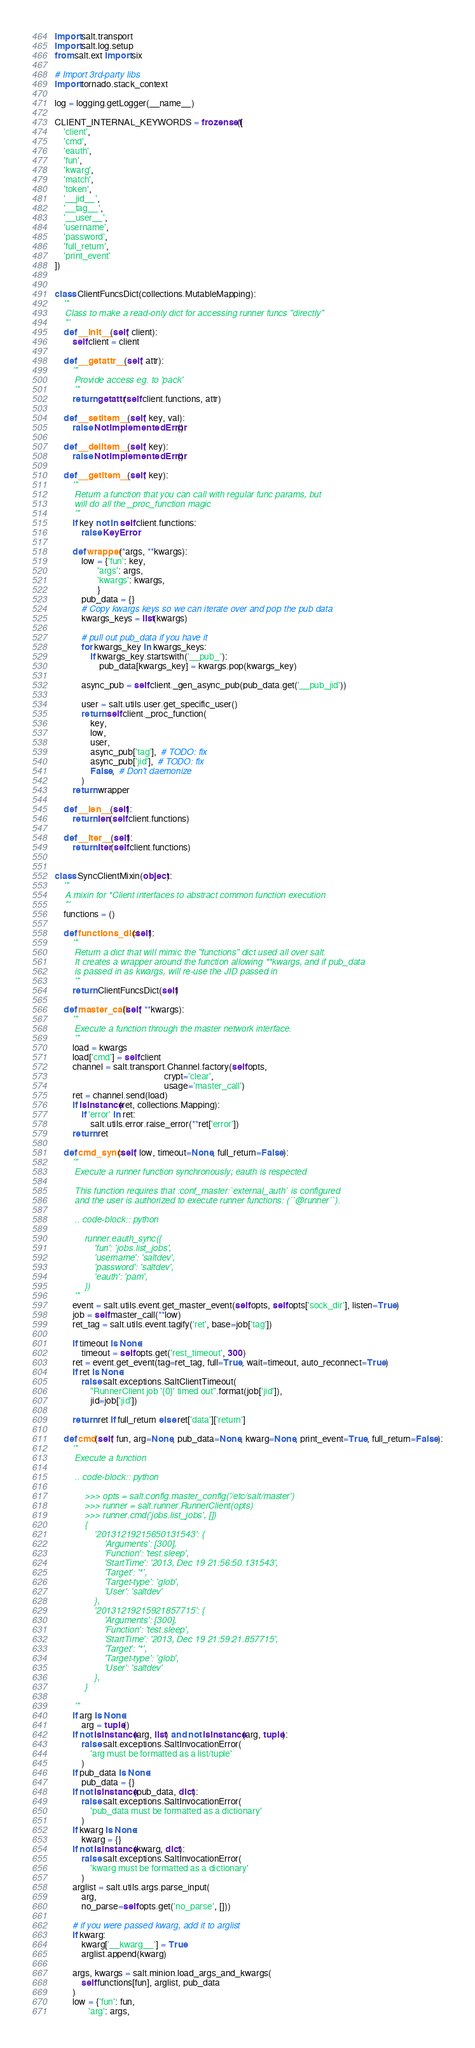<code> <loc_0><loc_0><loc_500><loc_500><_Python_>import salt.transport
import salt.log.setup
from salt.ext import six

# Import 3rd-party libs
import tornado.stack_context

log = logging.getLogger(__name__)

CLIENT_INTERNAL_KEYWORDS = frozenset([
    'client',
    'cmd',
    'eauth',
    'fun',
    'kwarg',
    'match',
    'token',
    '__jid__',
    '__tag__',
    '__user__',
    'username',
    'password',
    'full_return',
    'print_event'
])


class ClientFuncsDict(collections.MutableMapping):
    '''
    Class to make a read-only dict for accessing runner funcs "directly"
    '''
    def __init__(self, client):
        self.client = client

    def __getattr__(self, attr):
        '''
        Provide access eg. to 'pack'
        '''
        return getattr(self.client.functions, attr)

    def __setitem__(self, key, val):
        raise NotImplementedError()

    def __delitem__(self, key):
        raise NotImplementedError()

    def __getitem__(self, key):
        '''
        Return a function that you can call with regular func params, but
        will do all the _proc_function magic
        '''
        if key not in self.client.functions:
            raise KeyError

        def wrapper(*args, **kwargs):
            low = {'fun': key,
                   'args': args,
                   'kwargs': kwargs,
                   }
            pub_data = {}
            # Copy kwargs keys so we can iterate over and pop the pub data
            kwargs_keys = list(kwargs)

            # pull out pub_data if you have it
            for kwargs_key in kwargs_keys:
                if kwargs_key.startswith('__pub_'):
                    pub_data[kwargs_key] = kwargs.pop(kwargs_key)

            async_pub = self.client._gen_async_pub(pub_data.get('__pub_jid'))

            user = salt.utils.user.get_specific_user()
            return self.client._proc_function(
                key,
                low,
                user,
                async_pub['tag'],  # TODO: fix
                async_pub['jid'],  # TODO: fix
                False,  # Don't daemonize
            )
        return wrapper

    def __len__(self):
        return len(self.client.functions)

    def __iter__(self):
        return iter(self.client.functions)


class SyncClientMixin(object):
    '''
    A mixin for *Client interfaces to abstract common function execution
    '''
    functions = ()

    def functions_dict(self):
        '''
        Return a dict that will mimic the "functions" dict used all over salt.
        It creates a wrapper around the function allowing **kwargs, and if pub_data
        is passed in as kwargs, will re-use the JID passed in
        '''
        return ClientFuncsDict(self)

    def master_call(self, **kwargs):
        '''
        Execute a function through the master network interface.
        '''
        load = kwargs
        load['cmd'] = self.client
        channel = salt.transport.Channel.factory(self.opts,
                                                 crypt='clear',
                                                 usage='master_call')
        ret = channel.send(load)
        if isinstance(ret, collections.Mapping):
            if 'error' in ret:
                salt.utils.error.raise_error(**ret['error'])
        return ret

    def cmd_sync(self, low, timeout=None, full_return=False):
        '''
        Execute a runner function synchronously; eauth is respected

        This function requires that :conf_master:`external_auth` is configured
        and the user is authorized to execute runner functions: (``@runner``).

        .. code-block:: python

            runner.eauth_sync({
                'fun': 'jobs.list_jobs',
                'username': 'saltdev',
                'password': 'saltdev',
                'eauth': 'pam',
            })
        '''
        event = salt.utils.event.get_master_event(self.opts, self.opts['sock_dir'], listen=True)
        job = self.master_call(**low)
        ret_tag = salt.utils.event.tagify('ret', base=job['tag'])

        if timeout is None:
            timeout = self.opts.get('rest_timeout', 300)
        ret = event.get_event(tag=ret_tag, full=True, wait=timeout, auto_reconnect=True)
        if ret is None:
            raise salt.exceptions.SaltClientTimeout(
                "RunnerClient job '{0}' timed out".format(job['jid']),
                jid=job['jid'])

        return ret if full_return else ret['data']['return']

    def cmd(self, fun, arg=None, pub_data=None, kwarg=None, print_event=True, full_return=False):
        '''
        Execute a function

        .. code-block:: python

            >>> opts = salt.config.master_config('/etc/salt/master')
            >>> runner = salt.runner.RunnerClient(opts)
            >>> runner.cmd('jobs.list_jobs', [])
            {
                '20131219215650131543': {
                    'Arguments': [300],
                    'Function': 'test.sleep',
                    'StartTime': '2013, Dec 19 21:56:50.131543',
                    'Target': '*',
                    'Target-type': 'glob',
                    'User': 'saltdev'
                },
                '20131219215921857715': {
                    'Arguments': [300],
                    'Function': 'test.sleep',
                    'StartTime': '2013, Dec 19 21:59:21.857715',
                    'Target': '*',
                    'Target-type': 'glob',
                    'User': 'saltdev'
                },
            }

        '''
        if arg is None:
            arg = tuple()
        if not isinstance(arg, list) and not isinstance(arg, tuple):
            raise salt.exceptions.SaltInvocationError(
                'arg must be formatted as a list/tuple'
            )
        if pub_data is None:
            pub_data = {}
        if not isinstance(pub_data, dict):
            raise salt.exceptions.SaltInvocationError(
                'pub_data must be formatted as a dictionary'
            )
        if kwarg is None:
            kwarg = {}
        if not isinstance(kwarg, dict):
            raise salt.exceptions.SaltInvocationError(
                'kwarg must be formatted as a dictionary'
            )
        arglist = salt.utils.args.parse_input(
            arg,
            no_parse=self.opts.get('no_parse', []))

        # if you were passed kwarg, add it to arglist
        if kwarg:
            kwarg['__kwarg__'] = True
            arglist.append(kwarg)

        args, kwargs = salt.minion.load_args_and_kwargs(
            self.functions[fun], arglist, pub_data
        )
        low = {'fun': fun,
               'arg': args,</code> 